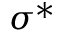<formula> <loc_0><loc_0><loc_500><loc_500>\sigma ^ { * }</formula> 